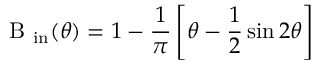<formula> <loc_0><loc_0><loc_500><loc_500>B _ { i n } ( \theta ) = 1 - \frac { 1 } { \pi } \left [ \theta - \frac { 1 } { 2 } \sin 2 \theta \right ]</formula> 